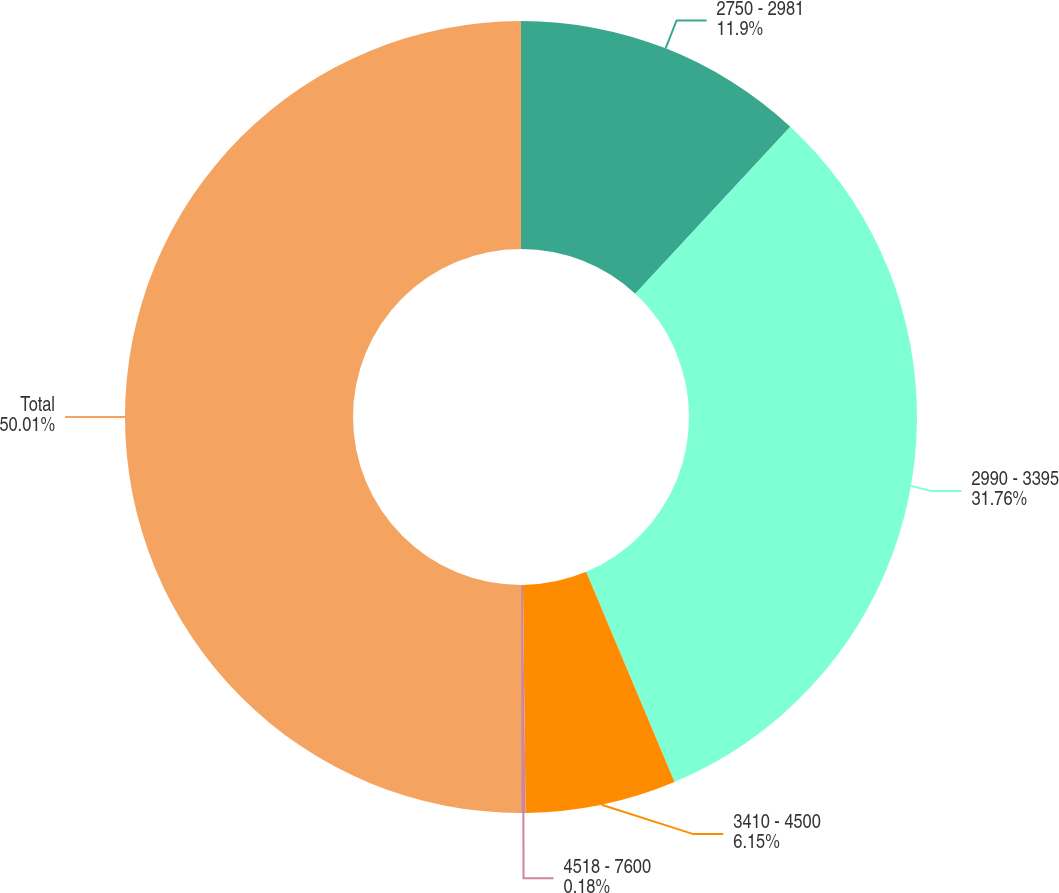Convert chart to OTSL. <chart><loc_0><loc_0><loc_500><loc_500><pie_chart><fcel>2750 - 2981<fcel>2990 - 3395<fcel>3410 - 4500<fcel>4518 - 7600<fcel>Total<nl><fcel>11.9%<fcel>31.76%<fcel>6.15%<fcel>0.18%<fcel>50.0%<nl></chart> 